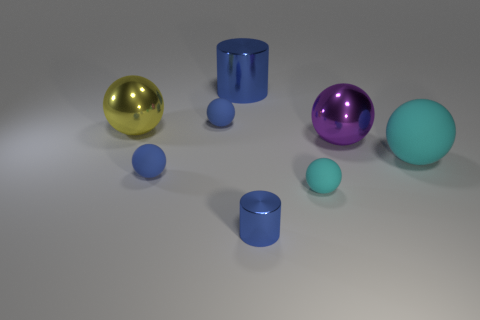Subtract all purple balls. How many balls are left? 5 Subtract all big yellow balls. How many balls are left? 5 Subtract all green balls. Subtract all brown cubes. How many balls are left? 6 Add 1 gray shiny cylinders. How many objects exist? 9 Subtract all balls. How many objects are left? 2 Add 3 cyan balls. How many cyan balls are left? 5 Add 3 shiny things. How many shiny things exist? 7 Subtract 1 purple balls. How many objects are left? 7 Subtract all small cyan matte cubes. Subtract all big purple metallic objects. How many objects are left? 7 